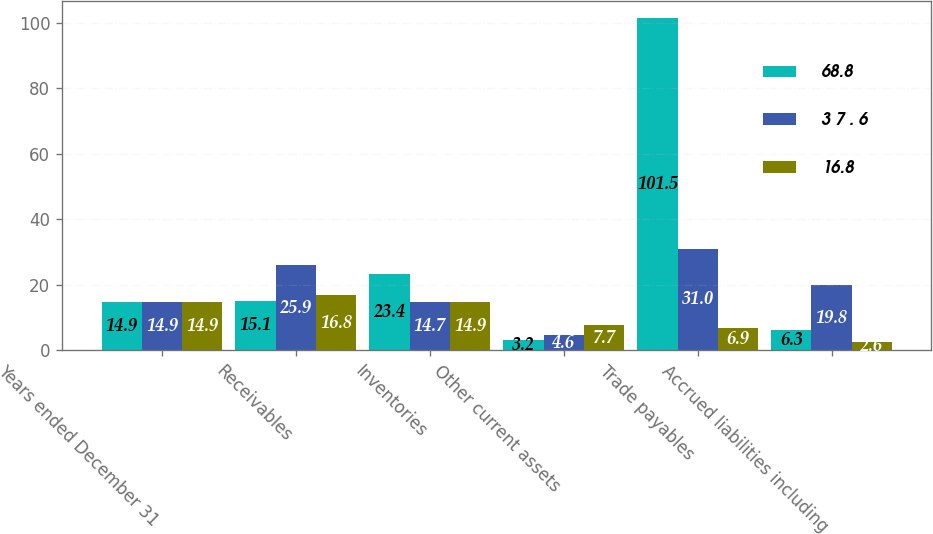Convert chart to OTSL. <chart><loc_0><loc_0><loc_500><loc_500><stacked_bar_chart><ecel><fcel>Years ended December 31<fcel>Receivables<fcel>Inventories<fcel>Other current assets<fcel>Trade payables<fcel>Accrued liabilities including<nl><fcel>68.8<fcel>14.9<fcel>15.1<fcel>23.4<fcel>3.2<fcel>101.5<fcel>6.3<nl><fcel>3 7 . 6<fcel>14.9<fcel>25.9<fcel>14.7<fcel>4.6<fcel>31<fcel>19.8<nl><fcel>16.8<fcel>14.9<fcel>16.8<fcel>14.9<fcel>7.7<fcel>6.9<fcel>2.6<nl></chart> 